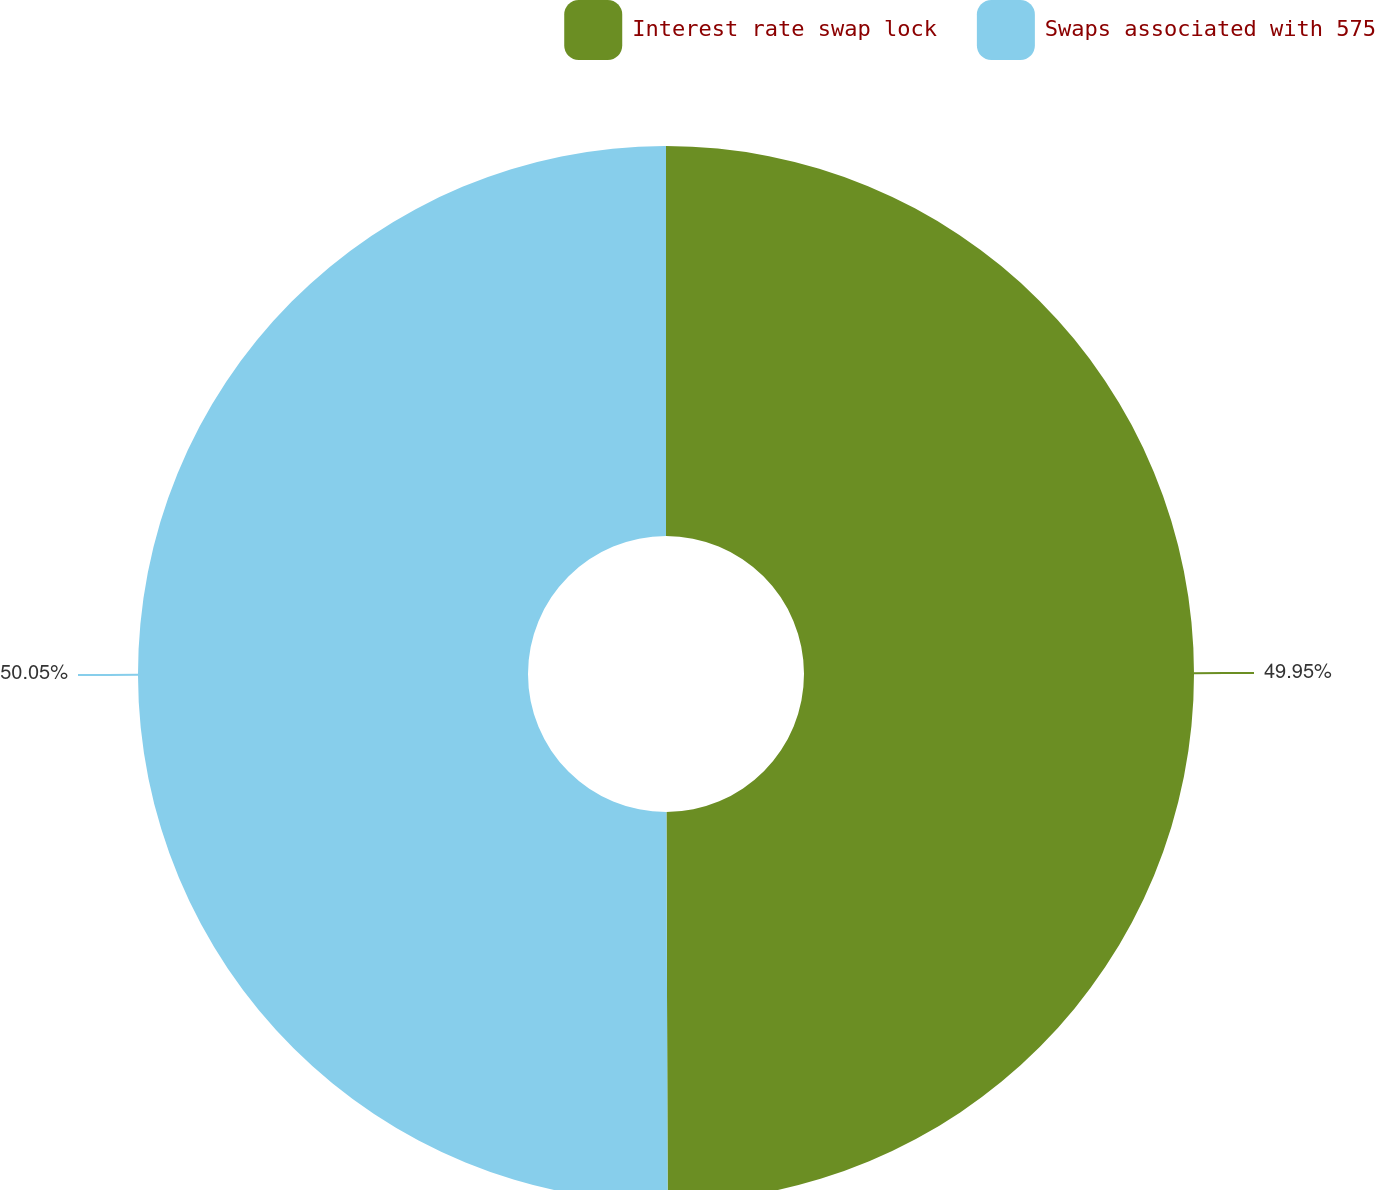Convert chart to OTSL. <chart><loc_0><loc_0><loc_500><loc_500><pie_chart><fcel>Interest rate swap lock<fcel>Swaps associated with 575<nl><fcel>49.95%<fcel>50.05%<nl></chart> 